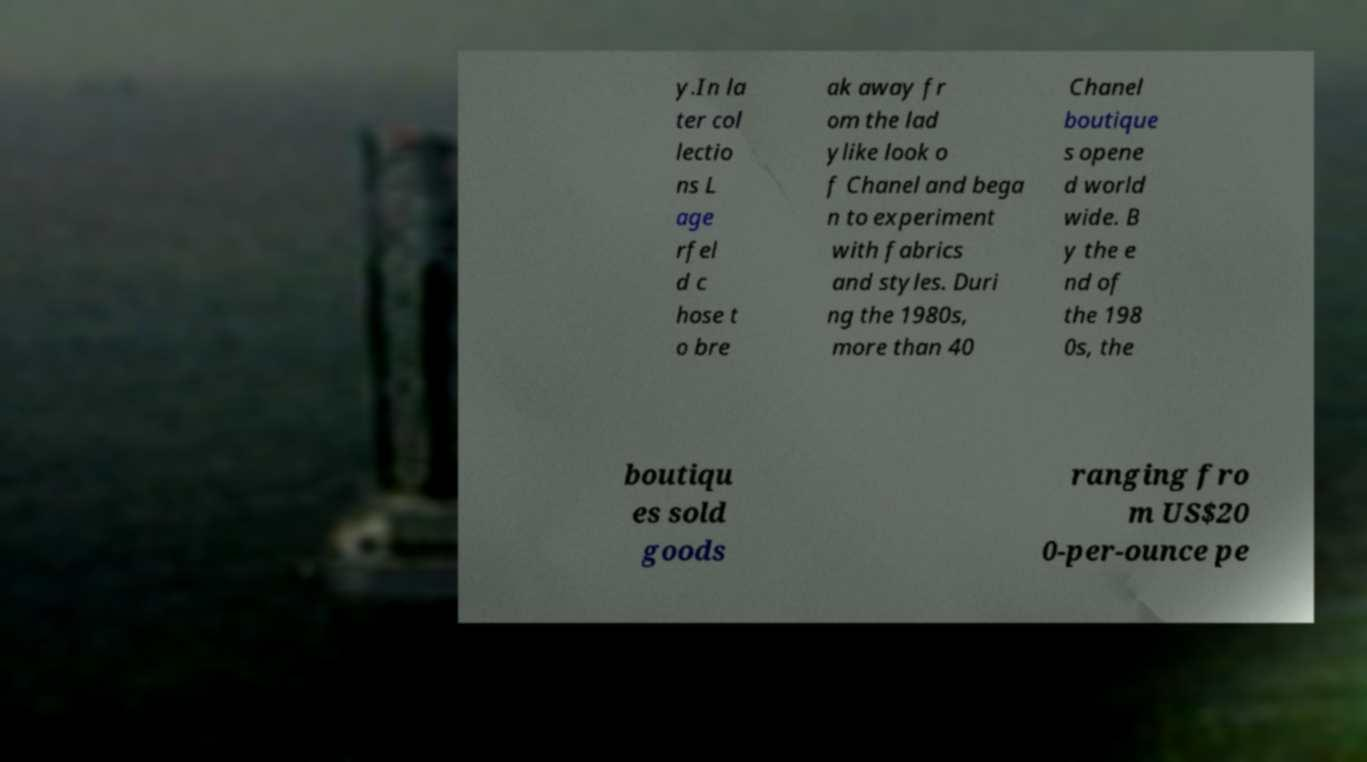Could you extract and type out the text from this image? y.In la ter col lectio ns L age rfel d c hose t o bre ak away fr om the lad ylike look o f Chanel and bega n to experiment with fabrics and styles. Duri ng the 1980s, more than 40 Chanel boutique s opene d world wide. B y the e nd of the 198 0s, the boutiqu es sold goods ranging fro m US$20 0-per-ounce pe 